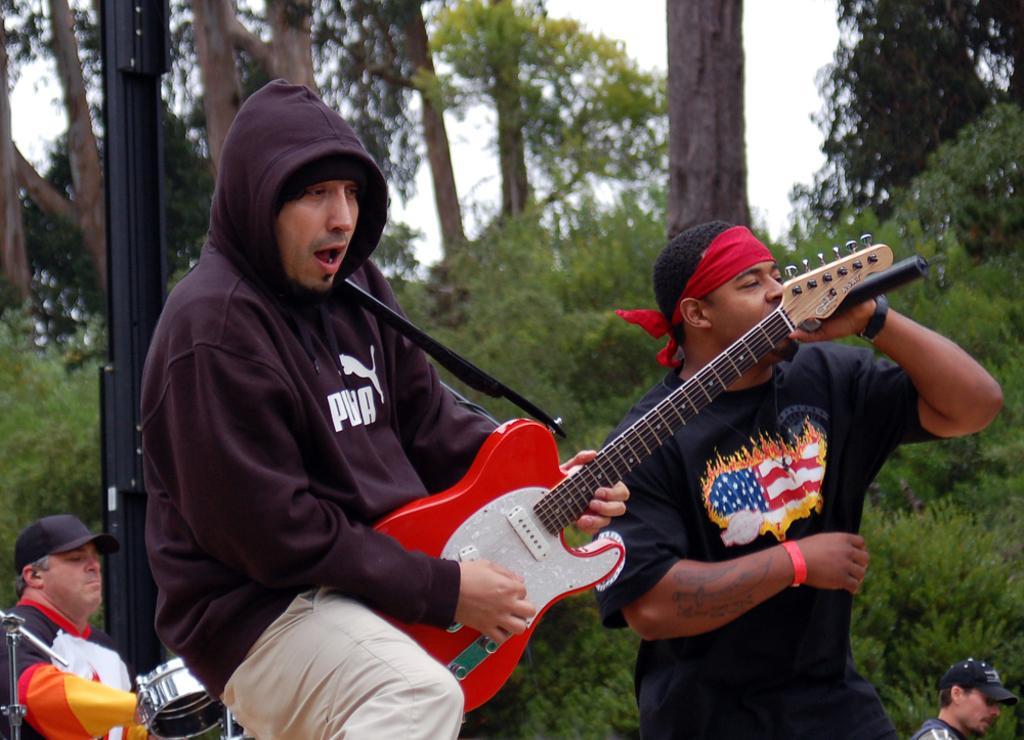How would you summarize this image in a sentence or two? The picture is taken in the middle of a forest. In the middle one man wearing maroon sweatshirt is playing guitar. In the right one man wearing black t-shirt is singing. He is holding a mic. In the left one man is playing drums. In the right bottom corner we can see another person. In the background there are trees. The sky is clear. 